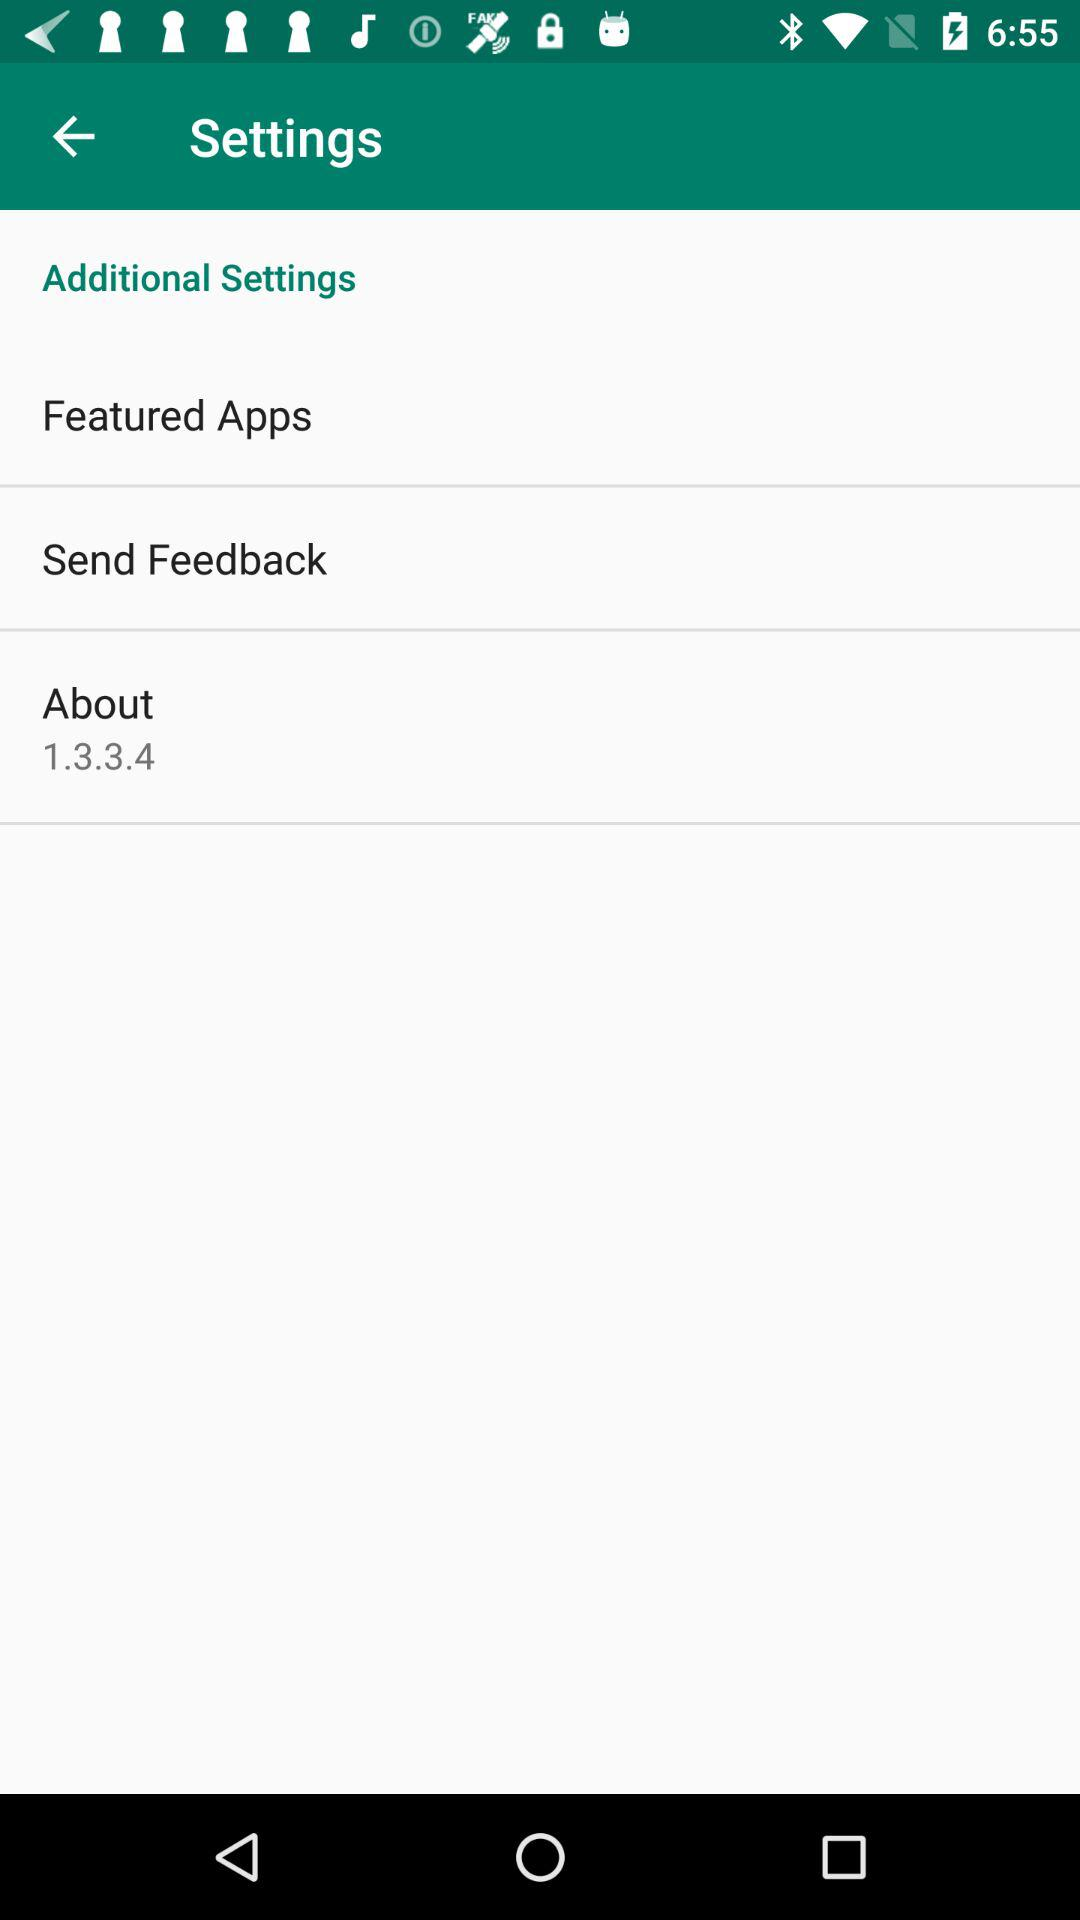What is the version? The version is 1.3.3.4. 